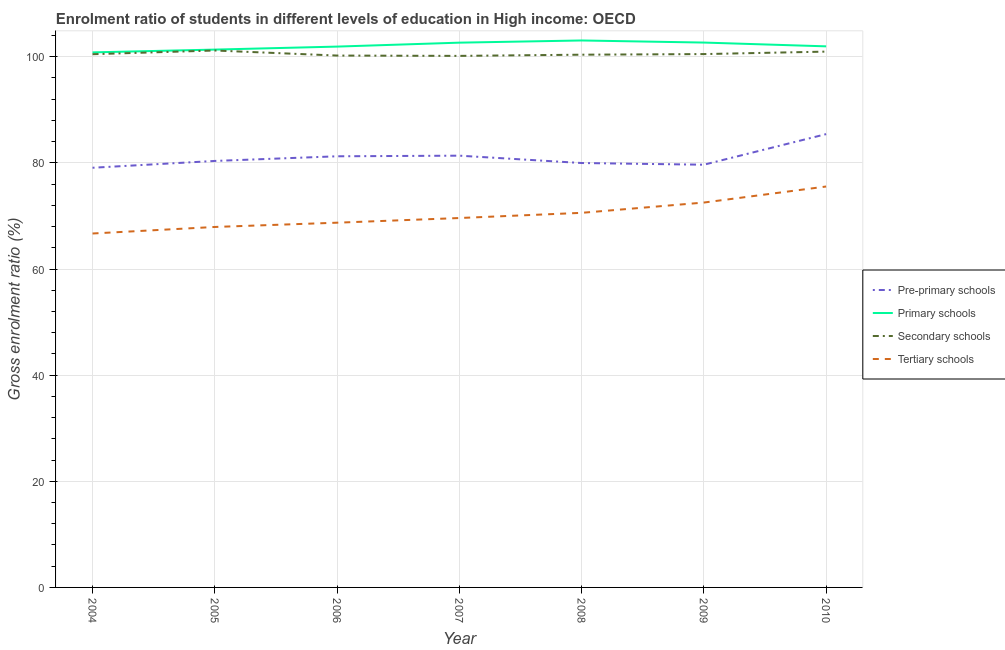How many different coloured lines are there?
Provide a succinct answer. 4. Does the line corresponding to gross enrolment ratio in pre-primary schools intersect with the line corresponding to gross enrolment ratio in tertiary schools?
Provide a short and direct response. No. What is the gross enrolment ratio in pre-primary schools in 2008?
Your answer should be compact. 79.98. Across all years, what is the maximum gross enrolment ratio in primary schools?
Keep it short and to the point. 103.07. Across all years, what is the minimum gross enrolment ratio in pre-primary schools?
Ensure brevity in your answer.  79.08. In which year was the gross enrolment ratio in tertiary schools maximum?
Your answer should be compact. 2010. What is the total gross enrolment ratio in secondary schools in the graph?
Offer a very short reply. 703.92. What is the difference between the gross enrolment ratio in secondary schools in 2008 and that in 2010?
Your response must be concise. -0.58. What is the difference between the gross enrolment ratio in tertiary schools in 2004 and the gross enrolment ratio in pre-primary schools in 2010?
Make the answer very short. -18.73. What is the average gross enrolment ratio in tertiary schools per year?
Offer a terse response. 70.23. In the year 2006, what is the difference between the gross enrolment ratio in pre-primary schools and gross enrolment ratio in tertiary schools?
Offer a terse response. 12.51. In how many years, is the gross enrolment ratio in primary schools greater than 4 %?
Give a very brief answer. 7. What is the ratio of the gross enrolment ratio in pre-primary schools in 2004 to that in 2010?
Give a very brief answer. 0.93. Is the difference between the gross enrolment ratio in tertiary schools in 2006 and 2008 greater than the difference between the gross enrolment ratio in primary schools in 2006 and 2008?
Provide a succinct answer. No. What is the difference between the highest and the second highest gross enrolment ratio in tertiary schools?
Give a very brief answer. 3.02. What is the difference between the highest and the lowest gross enrolment ratio in secondary schools?
Provide a short and direct response. 1.01. In how many years, is the gross enrolment ratio in pre-primary schools greater than the average gross enrolment ratio in pre-primary schools taken over all years?
Your answer should be very brief. 3. Is it the case that in every year, the sum of the gross enrolment ratio in secondary schools and gross enrolment ratio in pre-primary schools is greater than the sum of gross enrolment ratio in tertiary schools and gross enrolment ratio in primary schools?
Keep it short and to the point. No. Is it the case that in every year, the sum of the gross enrolment ratio in pre-primary schools and gross enrolment ratio in primary schools is greater than the gross enrolment ratio in secondary schools?
Your answer should be compact. Yes. Is the gross enrolment ratio in secondary schools strictly greater than the gross enrolment ratio in tertiary schools over the years?
Ensure brevity in your answer.  Yes. How many lines are there?
Keep it short and to the point. 4. What is the difference between two consecutive major ticks on the Y-axis?
Your answer should be very brief. 20. Where does the legend appear in the graph?
Provide a succinct answer. Center right. What is the title of the graph?
Your answer should be compact. Enrolment ratio of students in different levels of education in High income: OECD. Does "Portugal" appear as one of the legend labels in the graph?
Ensure brevity in your answer.  No. What is the label or title of the X-axis?
Offer a terse response. Year. What is the Gross enrolment ratio (%) of Pre-primary schools in 2004?
Provide a succinct answer. 79.08. What is the Gross enrolment ratio (%) in Primary schools in 2004?
Make the answer very short. 100.83. What is the Gross enrolment ratio (%) of Secondary schools in 2004?
Your answer should be compact. 100.48. What is the Gross enrolment ratio (%) of Tertiary schools in 2004?
Your response must be concise. 66.69. What is the Gross enrolment ratio (%) in Pre-primary schools in 2005?
Your answer should be very brief. 80.37. What is the Gross enrolment ratio (%) of Primary schools in 2005?
Your answer should be very brief. 101.35. What is the Gross enrolment ratio (%) of Secondary schools in 2005?
Your response must be concise. 101.18. What is the Gross enrolment ratio (%) in Tertiary schools in 2005?
Provide a succinct answer. 67.93. What is the Gross enrolment ratio (%) of Pre-primary schools in 2006?
Your response must be concise. 81.24. What is the Gross enrolment ratio (%) in Primary schools in 2006?
Ensure brevity in your answer.  101.92. What is the Gross enrolment ratio (%) of Secondary schools in 2006?
Keep it short and to the point. 100.23. What is the Gross enrolment ratio (%) in Tertiary schools in 2006?
Offer a very short reply. 68.73. What is the Gross enrolment ratio (%) of Pre-primary schools in 2007?
Keep it short and to the point. 81.36. What is the Gross enrolment ratio (%) in Primary schools in 2007?
Make the answer very short. 102.66. What is the Gross enrolment ratio (%) in Secondary schools in 2007?
Provide a succinct answer. 100.17. What is the Gross enrolment ratio (%) in Tertiary schools in 2007?
Offer a very short reply. 69.61. What is the Gross enrolment ratio (%) of Pre-primary schools in 2008?
Make the answer very short. 79.98. What is the Gross enrolment ratio (%) of Primary schools in 2008?
Your answer should be compact. 103.07. What is the Gross enrolment ratio (%) in Secondary schools in 2008?
Give a very brief answer. 100.39. What is the Gross enrolment ratio (%) in Tertiary schools in 2008?
Offer a very short reply. 70.59. What is the Gross enrolment ratio (%) of Pre-primary schools in 2009?
Provide a succinct answer. 79.66. What is the Gross enrolment ratio (%) in Primary schools in 2009?
Ensure brevity in your answer.  102.68. What is the Gross enrolment ratio (%) of Secondary schools in 2009?
Make the answer very short. 100.51. What is the Gross enrolment ratio (%) of Tertiary schools in 2009?
Offer a terse response. 72.53. What is the Gross enrolment ratio (%) of Pre-primary schools in 2010?
Your response must be concise. 85.42. What is the Gross enrolment ratio (%) of Primary schools in 2010?
Your response must be concise. 101.96. What is the Gross enrolment ratio (%) in Secondary schools in 2010?
Provide a short and direct response. 100.97. What is the Gross enrolment ratio (%) in Tertiary schools in 2010?
Give a very brief answer. 75.55. Across all years, what is the maximum Gross enrolment ratio (%) in Pre-primary schools?
Make the answer very short. 85.42. Across all years, what is the maximum Gross enrolment ratio (%) of Primary schools?
Provide a short and direct response. 103.07. Across all years, what is the maximum Gross enrolment ratio (%) in Secondary schools?
Your answer should be compact. 101.18. Across all years, what is the maximum Gross enrolment ratio (%) in Tertiary schools?
Your answer should be very brief. 75.55. Across all years, what is the minimum Gross enrolment ratio (%) of Pre-primary schools?
Provide a short and direct response. 79.08. Across all years, what is the minimum Gross enrolment ratio (%) in Primary schools?
Provide a succinct answer. 100.83. Across all years, what is the minimum Gross enrolment ratio (%) of Secondary schools?
Your answer should be very brief. 100.17. Across all years, what is the minimum Gross enrolment ratio (%) of Tertiary schools?
Your response must be concise. 66.69. What is the total Gross enrolment ratio (%) of Pre-primary schools in the graph?
Keep it short and to the point. 567.12. What is the total Gross enrolment ratio (%) in Primary schools in the graph?
Give a very brief answer. 714.46. What is the total Gross enrolment ratio (%) of Secondary schools in the graph?
Your response must be concise. 703.92. What is the total Gross enrolment ratio (%) of Tertiary schools in the graph?
Your answer should be compact. 491.63. What is the difference between the Gross enrolment ratio (%) of Pre-primary schools in 2004 and that in 2005?
Ensure brevity in your answer.  -1.28. What is the difference between the Gross enrolment ratio (%) of Primary schools in 2004 and that in 2005?
Your response must be concise. -0.52. What is the difference between the Gross enrolment ratio (%) of Secondary schools in 2004 and that in 2005?
Provide a succinct answer. -0.7. What is the difference between the Gross enrolment ratio (%) in Tertiary schools in 2004 and that in 2005?
Offer a very short reply. -1.23. What is the difference between the Gross enrolment ratio (%) in Pre-primary schools in 2004 and that in 2006?
Make the answer very short. -2.16. What is the difference between the Gross enrolment ratio (%) in Primary schools in 2004 and that in 2006?
Provide a short and direct response. -1.09. What is the difference between the Gross enrolment ratio (%) in Secondary schools in 2004 and that in 2006?
Keep it short and to the point. 0.25. What is the difference between the Gross enrolment ratio (%) of Tertiary schools in 2004 and that in 2006?
Make the answer very short. -2.04. What is the difference between the Gross enrolment ratio (%) in Pre-primary schools in 2004 and that in 2007?
Your answer should be very brief. -2.28. What is the difference between the Gross enrolment ratio (%) of Primary schools in 2004 and that in 2007?
Keep it short and to the point. -1.83. What is the difference between the Gross enrolment ratio (%) of Secondary schools in 2004 and that in 2007?
Your response must be concise. 0.32. What is the difference between the Gross enrolment ratio (%) of Tertiary schools in 2004 and that in 2007?
Ensure brevity in your answer.  -2.92. What is the difference between the Gross enrolment ratio (%) in Pre-primary schools in 2004 and that in 2008?
Offer a terse response. -0.89. What is the difference between the Gross enrolment ratio (%) in Primary schools in 2004 and that in 2008?
Keep it short and to the point. -2.24. What is the difference between the Gross enrolment ratio (%) of Secondary schools in 2004 and that in 2008?
Make the answer very short. 0.09. What is the difference between the Gross enrolment ratio (%) in Tertiary schools in 2004 and that in 2008?
Offer a terse response. -3.89. What is the difference between the Gross enrolment ratio (%) in Pre-primary schools in 2004 and that in 2009?
Your answer should be compact. -0.57. What is the difference between the Gross enrolment ratio (%) in Primary schools in 2004 and that in 2009?
Make the answer very short. -1.85. What is the difference between the Gross enrolment ratio (%) in Secondary schools in 2004 and that in 2009?
Your answer should be very brief. -0.02. What is the difference between the Gross enrolment ratio (%) of Tertiary schools in 2004 and that in 2009?
Make the answer very short. -5.83. What is the difference between the Gross enrolment ratio (%) of Pre-primary schools in 2004 and that in 2010?
Make the answer very short. -6.34. What is the difference between the Gross enrolment ratio (%) in Primary schools in 2004 and that in 2010?
Provide a succinct answer. -1.14. What is the difference between the Gross enrolment ratio (%) of Secondary schools in 2004 and that in 2010?
Ensure brevity in your answer.  -0.49. What is the difference between the Gross enrolment ratio (%) in Tertiary schools in 2004 and that in 2010?
Your response must be concise. -8.85. What is the difference between the Gross enrolment ratio (%) in Pre-primary schools in 2005 and that in 2006?
Offer a very short reply. -0.88. What is the difference between the Gross enrolment ratio (%) of Primary schools in 2005 and that in 2006?
Make the answer very short. -0.57. What is the difference between the Gross enrolment ratio (%) in Secondary schools in 2005 and that in 2006?
Provide a short and direct response. 0.95. What is the difference between the Gross enrolment ratio (%) of Tertiary schools in 2005 and that in 2006?
Your answer should be very brief. -0.81. What is the difference between the Gross enrolment ratio (%) in Pre-primary schools in 2005 and that in 2007?
Ensure brevity in your answer.  -0.99. What is the difference between the Gross enrolment ratio (%) in Primary schools in 2005 and that in 2007?
Provide a succinct answer. -1.31. What is the difference between the Gross enrolment ratio (%) in Secondary schools in 2005 and that in 2007?
Provide a short and direct response. 1.01. What is the difference between the Gross enrolment ratio (%) in Tertiary schools in 2005 and that in 2007?
Make the answer very short. -1.69. What is the difference between the Gross enrolment ratio (%) in Pre-primary schools in 2005 and that in 2008?
Your answer should be compact. 0.39. What is the difference between the Gross enrolment ratio (%) in Primary schools in 2005 and that in 2008?
Keep it short and to the point. -1.72. What is the difference between the Gross enrolment ratio (%) in Secondary schools in 2005 and that in 2008?
Ensure brevity in your answer.  0.79. What is the difference between the Gross enrolment ratio (%) of Tertiary schools in 2005 and that in 2008?
Make the answer very short. -2.66. What is the difference between the Gross enrolment ratio (%) in Pre-primary schools in 2005 and that in 2009?
Offer a very short reply. 0.71. What is the difference between the Gross enrolment ratio (%) in Primary schools in 2005 and that in 2009?
Keep it short and to the point. -1.33. What is the difference between the Gross enrolment ratio (%) of Secondary schools in 2005 and that in 2009?
Ensure brevity in your answer.  0.67. What is the difference between the Gross enrolment ratio (%) in Tertiary schools in 2005 and that in 2009?
Give a very brief answer. -4.6. What is the difference between the Gross enrolment ratio (%) in Pre-primary schools in 2005 and that in 2010?
Offer a very short reply. -5.05. What is the difference between the Gross enrolment ratio (%) of Primary schools in 2005 and that in 2010?
Offer a very short reply. -0.61. What is the difference between the Gross enrolment ratio (%) in Secondary schools in 2005 and that in 2010?
Offer a terse response. 0.21. What is the difference between the Gross enrolment ratio (%) of Tertiary schools in 2005 and that in 2010?
Give a very brief answer. -7.62. What is the difference between the Gross enrolment ratio (%) of Pre-primary schools in 2006 and that in 2007?
Ensure brevity in your answer.  -0.12. What is the difference between the Gross enrolment ratio (%) of Primary schools in 2006 and that in 2007?
Your response must be concise. -0.74. What is the difference between the Gross enrolment ratio (%) in Secondary schools in 2006 and that in 2007?
Your response must be concise. 0.06. What is the difference between the Gross enrolment ratio (%) of Tertiary schools in 2006 and that in 2007?
Keep it short and to the point. -0.88. What is the difference between the Gross enrolment ratio (%) of Pre-primary schools in 2006 and that in 2008?
Give a very brief answer. 1.27. What is the difference between the Gross enrolment ratio (%) of Primary schools in 2006 and that in 2008?
Your response must be concise. -1.15. What is the difference between the Gross enrolment ratio (%) in Secondary schools in 2006 and that in 2008?
Your answer should be very brief. -0.16. What is the difference between the Gross enrolment ratio (%) in Tertiary schools in 2006 and that in 2008?
Provide a short and direct response. -1.86. What is the difference between the Gross enrolment ratio (%) of Pre-primary schools in 2006 and that in 2009?
Ensure brevity in your answer.  1.59. What is the difference between the Gross enrolment ratio (%) of Primary schools in 2006 and that in 2009?
Make the answer very short. -0.76. What is the difference between the Gross enrolment ratio (%) of Secondary schools in 2006 and that in 2009?
Ensure brevity in your answer.  -0.28. What is the difference between the Gross enrolment ratio (%) of Tertiary schools in 2006 and that in 2009?
Offer a terse response. -3.8. What is the difference between the Gross enrolment ratio (%) in Pre-primary schools in 2006 and that in 2010?
Provide a short and direct response. -4.18. What is the difference between the Gross enrolment ratio (%) of Primary schools in 2006 and that in 2010?
Your answer should be compact. -0.05. What is the difference between the Gross enrolment ratio (%) in Secondary schools in 2006 and that in 2010?
Provide a short and direct response. -0.74. What is the difference between the Gross enrolment ratio (%) in Tertiary schools in 2006 and that in 2010?
Offer a terse response. -6.82. What is the difference between the Gross enrolment ratio (%) of Pre-primary schools in 2007 and that in 2008?
Provide a succinct answer. 1.38. What is the difference between the Gross enrolment ratio (%) in Primary schools in 2007 and that in 2008?
Ensure brevity in your answer.  -0.41. What is the difference between the Gross enrolment ratio (%) of Secondary schools in 2007 and that in 2008?
Provide a short and direct response. -0.22. What is the difference between the Gross enrolment ratio (%) in Tertiary schools in 2007 and that in 2008?
Keep it short and to the point. -0.98. What is the difference between the Gross enrolment ratio (%) of Pre-primary schools in 2007 and that in 2009?
Your response must be concise. 1.7. What is the difference between the Gross enrolment ratio (%) in Primary schools in 2007 and that in 2009?
Keep it short and to the point. -0.02. What is the difference between the Gross enrolment ratio (%) in Secondary schools in 2007 and that in 2009?
Make the answer very short. -0.34. What is the difference between the Gross enrolment ratio (%) in Tertiary schools in 2007 and that in 2009?
Provide a succinct answer. -2.92. What is the difference between the Gross enrolment ratio (%) of Pre-primary schools in 2007 and that in 2010?
Your answer should be compact. -4.06. What is the difference between the Gross enrolment ratio (%) in Primary schools in 2007 and that in 2010?
Ensure brevity in your answer.  0.7. What is the difference between the Gross enrolment ratio (%) of Secondary schools in 2007 and that in 2010?
Offer a terse response. -0.81. What is the difference between the Gross enrolment ratio (%) of Tertiary schools in 2007 and that in 2010?
Keep it short and to the point. -5.94. What is the difference between the Gross enrolment ratio (%) in Pre-primary schools in 2008 and that in 2009?
Ensure brevity in your answer.  0.32. What is the difference between the Gross enrolment ratio (%) of Primary schools in 2008 and that in 2009?
Offer a terse response. 0.39. What is the difference between the Gross enrolment ratio (%) of Secondary schools in 2008 and that in 2009?
Give a very brief answer. -0.12. What is the difference between the Gross enrolment ratio (%) of Tertiary schools in 2008 and that in 2009?
Keep it short and to the point. -1.94. What is the difference between the Gross enrolment ratio (%) of Pre-primary schools in 2008 and that in 2010?
Give a very brief answer. -5.45. What is the difference between the Gross enrolment ratio (%) of Primary schools in 2008 and that in 2010?
Keep it short and to the point. 1.11. What is the difference between the Gross enrolment ratio (%) of Secondary schools in 2008 and that in 2010?
Give a very brief answer. -0.58. What is the difference between the Gross enrolment ratio (%) in Tertiary schools in 2008 and that in 2010?
Offer a very short reply. -4.96. What is the difference between the Gross enrolment ratio (%) in Pre-primary schools in 2009 and that in 2010?
Provide a short and direct response. -5.76. What is the difference between the Gross enrolment ratio (%) in Primary schools in 2009 and that in 2010?
Your response must be concise. 0.71. What is the difference between the Gross enrolment ratio (%) in Secondary schools in 2009 and that in 2010?
Make the answer very short. -0.47. What is the difference between the Gross enrolment ratio (%) in Tertiary schools in 2009 and that in 2010?
Your response must be concise. -3.02. What is the difference between the Gross enrolment ratio (%) of Pre-primary schools in 2004 and the Gross enrolment ratio (%) of Primary schools in 2005?
Your answer should be compact. -22.27. What is the difference between the Gross enrolment ratio (%) in Pre-primary schools in 2004 and the Gross enrolment ratio (%) in Secondary schools in 2005?
Provide a succinct answer. -22.1. What is the difference between the Gross enrolment ratio (%) of Pre-primary schools in 2004 and the Gross enrolment ratio (%) of Tertiary schools in 2005?
Make the answer very short. 11.16. What is the difference between the Gross enrolment ratio (%) in Primary schools in 2004 and the Gross enrolment ratio (%) in Secondary schools in 2005?
Your answer should be compact. -0.36. What is the difference between the Gross enrolment ratio (%) of Primary schools in 2004 and the Gross enrolment ratio (%) of Tertiary schools in 2005?
Offer a very short reply. 32.9. What is the difference between the Gross enrolment ratio (%) in Secondary schools in 2004 and the Gross enrolment ratio (%) in Tertiary schools in 2005?
Ensure brevity in your answer.  32.55. What is the difference between the Gross enrolment ratio (%) in Pre-primary schools in 2004 and the Gross enrolment ratio (%) in Primary schools in 2006?
Keep it short and to the point. -22.83. What is the difference between the Gross enrolment ratio (%) in Pre-primary schools in 2004 and the Gross enrolment ratio (%) in Secondary schools in 2006?
Offer a very short reply. -21.14. What is the difference between the Gross enrolment ratio (%) of Pre-primary schools in 2004 and the Gross enrolment ratio (%) of Tertiary schools in 2006?
Offer a terse response. 10.35. What is the difference between the Gross enrolment ratio (%) of Primary schools in 2004 and the Gross enrolment ratio (%) of Secondary schools in 2006?
Make the answer very short. 0.6. What is the difference between the Gross enrolment ratio (%) in Primary schools in 2004 and the Gross enrolment ratio (%) in Tertiary schools in 2006?
Your answer should be very brief. 32.09. What is the difference between the Gross enrolment ratio (%) of Secondary schools in 2004 and the Gross enrolment ratio (%) of Tertiary schools in 2006?
Your response must be concise. 31.75. What is the difference between the Gross enrolment ratio (%) of Pre-primary schools in 2004 and the Gross enrolment ratio (%) of Primary schools in 2007?
Make the answer very short. -23.57. What is the difference between the Gross enrolment ratio (%) in Pre-primary schools in 2004 and the Gross enrolment ratio (%) in Secondary schools in 2007?
Provide a short and direct response. -21.08. What is the difference between the Gross enrolment ratio (%) of Pre-primary schools in 2004 and the Gross enrolment ratio (%) of Tertiary schools in 2007?
Make the answer very short. 9.47. What is the difference between the Gross enrolment ratio (%) of Primary schools in 2004 and the Gross enrolment ratio (%) of Secondary schools in 2007?
Keep it short and to the point. 0.66. What is the difference between the Gross enrolment ratio (%) of Primary schools in 2004 and the Gross enrolment ratio (%) of Tertiary schools in 2007?
Ensure brevity in your answer.  31.21. What is the difference between the Gross enrolment ratio (%) of Secondary schools in 2004 and the Gross enrolment ratio (%) of Tertiary schools in 2007?
Ensure brevity in your answer.  30.87. What is the difference between the Gross enrolment ratio (%) of Pre-primary schools in 2004 and the Gross enrolment ratio (%) of Primary schools in 2008?
Offer a very short reply. -23.99. What is the difference between the Gross enrolment ratio (%) in Pre-primary schools in 2004 and the Gross enrolment ratio (%) in Secondary schools in 2008?
Offer a terse response. -21.31. What is the difference between the Gross enrolment ratio (%) in Pre-primary schools in 2004 and the Gross enrolment ratio (%) in Tertiary schools in 2008?
Provide a short and direct response. 8.49. What is the difference between the Gross enrolment ratio (%) of Primary schools in 2004 and the Gross enrolment ratio (%) of Secondary schools in 2008?
Provide a short and direct response. 0.44. What is the difference between the Gross enrolment ratio (%) of Primary schools in 2004 and the Gross enrolment ratio (%) of Tertiary schools in 2008?
Offer a very short reply. 30.24. What is the difference between the Gross enrolment ratio (%) of Secondary schools in 2004 and the Gross enrolment ratio (%) of Tertiary schools in 2008?
Your response must be concise. 29.89. What is the difference between the Gross enrolment ratio (%) of Pre-primary schools in 2004 and the Gross enrolment ratio (%) of Primary schools in 2009?
Provide a short and direct response. -23.59. What is the difference between the Gross enrolment ratio (%) of Pre-primary schools in 2004 and the Gross enrolment ratio (%) of Secondary schools in 2009?
Provide a succinct answer. -21.42. What is the difference between the Gross enrolment ratio (%) in Pre-primary schools in 2004 and the Gross enrolment ratio (%) in Tertiary schools in 2009?
Offer a very short reply. 6.56. What is the difference between the Gross enrolment ratio (%) in Primary schools in 2004 and the Gross enrolment ratio (%) in Secondary schools in 2009?
Your response must be concise. 0.32. What is the difference between the Gross enrolment ratio (%) in Primary schools in 2004 and the Gross enrolment ratio (%) in Tertiary schools in 2009?
Offer a terse response. 28.3. What is the difference between the Gross enrolment ratio (%) in Secondary schools in 2004 and the Gross enrolment ratio (%) in Tertiary schools in 2009?
Provide a short and direct response. 27.95. What is the difference between the Gross enrolment ratio (%) of Pre-primary schools in 2004 and the Gross enrolment ratio (%) of Primary schools in 2010?
Ensure brevity in your answer.  -22.88. What is the difference between the Gross enrolment ratio (%) of Pre-primary schools in 2004 and the Gross enrolment ratio (%) of Secondary schools in 2010?
Ensure brevity in your answer.  -21.89. What is the difference between the Gross enrolment ratio (%) of Pre-primary schools in 2004 and the Gross enrolment ratio (%) of Tertiary schools in 2010?
Provide a short and direct response. 3.53. What is the difference between the Gross enrolment ratio (%) of Primary schools in 2004 and the Gross enrolment ratio (%) of Secondary schools in 2010?
Your answer should be compact. -0.15. What is the difference between the Gross enrolment ratio (%) of Primary schools in 2004 and the Gross enrolment ratio (%) of Tertiary schools in 2010?
Provide a succinct answer. 25.28. What is the difference between the Gross enrolment ratio (%) of Secondary schools in 2004 and the Gross enrolment ratio (%) of Tertiary schools in 2010?
Your answer should be compact. 24.93. What is the difference between the Gross enrolment ratio (%) of Pre-primary schools in 2005 and the Gross enrolment ratio (%) of Primary schools in 2006?
Give a very brief answer. -21.55. What is the difference between the Gross enrolment ratio (%) in Pre-primary schools in 2005 and the Gross enrolment ratio (%) in Secondary schools in 2006?
Offer a terse response. -19.86. What is the difference between the Gross enrolment ratio (%) of Pre-primary schools in 2005 and the Gross enrolment ratio (%) of Tertiary schools in 2006?
Keep it short and to the point. 11.64. What is the difference between the Gross enrolment ratio (%) of Primary schools in 2005 and the Gross enrolment ratio (%) of Secondary schools in 2006?
Ensure brevity in your answer.  1.12. What is the difference between the Gross enrolment ratio (%) in Primary schools in 2005 and the Gross enrolment ratio (%) in Tertiary schools in 2006?
Give a very brief answer. 32.62. What is the difference between the Gross enrolment ratio (%) in Secondary schools in 2005 and the Gross enrolment ratio (%) in Tertiary schools in 2006?
Offer a terse response. 32.45. What is the difference between the Gross enrolment ratio (%) of Pre-primary schools in 2005 and the Gross enrolment ratio (%) of Primary schools in 2007?
Your response must be concise. -22.29. What is the difference between the Gross enrolment ratio (%) of Pre-primary schools in 2005 and the Gross enrolment ratio (%) of Secondary schools in 2007?
Provide a succinct answer. -19.8. What is the difference between the Gross enrolment ratio (%) of Pre-primary schools in 2005 and the Gross enrolment ratio (%) of Tertiary schools in 2007?
Your answer should be compact. 10.76. What is the difference between the Gross enrolment ratio (%) in Primary schools in 2005 and the Gross enrolment ratio (%) in Secondary schools in 2007?
Your response must be concise. 1.18. What is the difference between the Gross enrolment ratio (%) of Primary schools in 2005 and the Gross enrolment ratio (%) of Tertiary schools in 2007?
Keep it short and to the point. 31.74. What is the difference between the Gross enrolment ratio (%) of Secondary schools in 2005 and the Gross enrolment ratio (%) of Tertiary schools in 2007?
Keep it short and to the point. 31.57. What is the difference between the Gross enrolment ratio (%) in Pre-primary schools in 2005 and the Gross enrolment ratio (%) in Primary schools in 2008?
Your answer should be very brief. -22.7. What is the difference between the Gross enrolment ratio (%) of Pre-primary schools in 2005 and the Gross enrolment ratio (%) of Secondary schools in 2008?
Ensure brevity in your answer.  -20.02. What is the difference between the Gross enrolment ratio (%) in Pre-primary schools in 2005 and the Gross enrolment ratio (%) in Tertiary schools in 2008?
Make the answer very short. 9.78. What is the difference between the Gross enrolment ratio (%) in Primary schools in 2005 and the Gross enrolment ratio (%) in Secondary schools in 2008?
Your answer should be very brief. 0.96. What is the difference between the Gross enrolment ratio (%) in Primary schools in 2005 and the Gross enrolment ratio (%) in Tertiary schools in 2008?
Offer a terse response. 30.76. What is the difference between the Gross enrolment ratio (%) in Secondary schools in 2005 and the Gross enrolment ratio (%) in Tertiary schools in 2008?
Offer a terse response. 30.59. What is the difference between the Gross enrolment ratio (%) in Pre-primary schools in 2005 and the Gross enrolment ratio (%) in Primary schools in 2009?
Your response must be concise. -22.31. What is the difference between the Gross enrolment ratio (%) of Pre-primary schools in 2005 and the Gross enrolment ratio (%) of Secondary schools in 2009?
Give a very brief answer. -20.14. What is the difference between the Gross enrolment ratio (%) of Pre-primary schools in 2005 and the Gross enrolment ratio (%) of Tertiary schools in 2009?
Keep it short and to the point. 7.84. What is the difference between the Gross enrolment ratio (%) in Primary schools in 2005 and the Gross enrolment ratio (%) in Secondary schools in 2009?
Provide a short and direct response. 0.84. What is the difference between the Gross enrolment ratio (%) in Primary schools in 2005 and the Gross enrolment ratio (%) in Tertiary schools in 2009?
Provide a short and direct response. 28.82. What is the difference between the Gross enrolment ratio (%) of Secondary schools in 2005 and the Gross enrolment ratio (%) of Tertiary schools in 2009?
Offer a terse response. 28.65. What is the difference between the Gross enrolment ratio (%) of Pre-primary schools in 2005 and the Gross enrolment ratio (%) of Primary schools in 2010?
Keep it short and to the point. -21.59. What is the difference between the Gross enrolment ratio (%) in Pre-primary schools in 2005 and the Gross enrolment ratio (%) in Secondary schools in 2010?
Your response must be concise. -20.6. What is the difference between the Gross enrolment ratio (%) of Pre-primary schools in 2005 and the Gross enrolment ratio (%) of Tertiary schools in 2010?
Offer a very short reply. 4.82. What is the difference between the Gross enrolment ratio (%) in Primary schools in 2005 and the Gross enrolment ratio (%) in Secondary schools in 2010?
Provide a short and direct response. 0.38. What is the difference between the Gross enrolment ratio (%) of Primary schools in 2005 and the Gross enrolment ratio (%) of Tertiary schools in 2010?
Make the answer very short. 25.8. What is the difference between the Gross enrolment ratio (%) in Secondary schools in 2005 and the Gross enrolment ratio (%) in Tertiary schools in 2010?
Your answer should be compact. 25.63. What is the difference between the Gross enrolment ratio (%) of Pre-primary schools in 2006 and the Gross enrolment ratio (%) of Primary schools in 2007?
Give a very brief answer. -21.41. What is the difference between the Gross enrolment ratio (%) in Pre-primary schools in 2006 and the Gross enrolment ratio (%) in Secondary schools in 2007?
Offer a terse response. -18.92. What is the difference between the Gross enrolment ratio (%) in Pre-primary schools in 2006 and the Gross enrolment ratio (%) in Tertiary schools in 2007?
Your answer should be very brief. 11.63. What is the difference between the Gross enrolment ratio (%) in Primary schools in 2006 and the Gross enrolment ratio (%) in Secondary schools in 2007?
Make the answer very short. 1.75. What is the difference between the Gross enrolment ratio (%) of Primary schools in 2006 and the Gross enrolment ratio (%) of Tertiary schools in 2007?
Provide a short and direct response. 32.31. What is the difference between the Gross enrolment ratio (%) in Secondary schools in 2006 and the Gross enrolment ratio (%) in Tertiary schools in 2007?
Your answer should be very brief. 30.61. What is the difference between the Gross enrolment ratio (%) of Pre-primary schools in 2006 and the Gross enrolment ratio (%) of Primary schools in 2008?
Make the answer very short. -21.82. What is the difference between the Gross enrolment ratio (%) in Pre-primary schools in 2006 and the Gross enrolment ratio (%) in Secondary schools in 2008?
Offer a terse response. -19.15. What is the difference between the Gross enrolment ratio (%) in Pre-primary schools in 2006 and the Gross enrolment ratio (%) in Tertiary schools in 2008?
Ensure brevity in your answer.  10.66. What is the difference between the Gross enrolment ratio (%) in Primary schools in 2006 and the Gross enrolment ratio (%) in Secondary schools in 2008?
Provide a short and direct response. 1.53. What is the difference between the Gross enrolment ratio (%) in Primary schools in 2006 and the Gross enrolment ratio (%) in Tertiary schools in 2008?
Provide a short and direct response. 31.33. What is the difference between the Gross enrolment ratio (%) in Secondary schools in 2006 and the Gross enrolment ratio (%) in Tertiary schools in 2008?
Offer a very short reply. 29.64. What is the difference between the Gross enrolment ratio (%) of Pre-primary schools in 2006 and the Gross enrolment ratio (%) of Primary schools in 2009?
Keep it short and to the point. -21.43. What is the difference between the Gross enrolment ratio (%) of Pre-primary schools in 2006 and the Gross enrolment ratio (%) of Secondary schools in 2009?
Offer a terse response. -19.26. What is the difference between the Gross enrolment ratio (%) of Pre-primary schools in 2006 and the Gross enrolment ratio (%) of Tertiary schools in 2009?
Offer a very short reply. 8.72. What is the difference between the Gross enrolment ratio (%) of Primary schools in 2006 and the Gross enrolment ratio (%) of Secondary schools in 2009?
Give a very brief answer. 1.41. What is the difference between the Gross enrolment ratio (%) of Primary schools in 2006 and the Gross enrolment ratio (%) of Tertiary schools in 2009?
Offer a terse response. 29.39. What is the difference between the Gross enrolment ratio (%) in Secondary schools in 2006 and the Gross enrolment ratio (%) in Tertiary schools in 2009?
Provide a short and direct response. 27.7. What is the difference between the Gross enrolment ratio (%) in Pre-primary schools in 2006 and the Gross enrolment ratio (%) in Primary schools in 2010?
Ensure brevity in your answer.  -20.72. What is the difference between the Gross enrolment ratio (%) of Pre-primary schools in 2006 and the Gross enrolment ratio (%) of Secondary schools in 2010?
Ensure brevity in your answer.  -19.73. What is the difference between the Gross enrolment ratio (%) in Pre-primary schools in 2006 and the Gross enrolment ratio (%) in Tertiary schools in 2010?
Your response must be concise. 5.7. What is the difference between the Gross enrolment ratio (%) of Primary schools in 2006 and the Gross enrolment ratio (%) of Secondary schools in 2010?
Provide a short and direct response. 0.95. What is the difference between the Gross enrolment ratio (%) in Primary schools in 2006 and the Gross enrolment ratio (%) in Tertiary schools in 2010?
Offer a very short reply. 26.37. What is the difference between the Gross enrolment ratio (%) of Secondary schools in 2006 and the Gross enrolment ratio (%) of Tertiary schools in 2010?
Provide a succinct answer. 24.68. What is the difference between the Gross enrolment ratio (%) in Pre-primary schools in 2007 and the Gross enrolment ratio (%) in Primary schools in 2008?
Keep it short and to the point. -21.71. What is the difference between the Gross enrolment ratio (%) in Pre-primary schools in 2007 and the Gross enrolment ratio (%) in Secondary schools in 2008?
Give a very brief answer. -19.03. What is the difference between the Gross enrolment ratio (%) in Pre-primary schools in 2007 and the Gross enrolment ratio (%) in Tertiary schools in 2008?
Offer a very short reply. 10.77. What is the difference between the Gross enrolment ratio (%) of Primary schools in 2007 and the Gross enrolment ratio (%) of Secondary schools in 2008?
Your answer should be compact. 2.27. What is the difference between the Gross enrolment ratio (%) of Primary schools in 2007 and the Gross enrolment ratio (%) of Tertiary schools in 2008?
Give a very brief answer. 32.07. What is the difference between the Gross enrolment ratio (%) in Secondary schools in 2007 and the Gross enrolment ratio (%) in Tertiary schools in 2008?
Make the answer very short. 29.58. What is the difference between the Gross enrolment ratio (%) of Pre-primary schools in 2007 and the Gross enrolment ratio (%) of Primary schools in 2009?
Keep it short and to the point. -21.31. What is the difference between the Gross enrolment ratio (%) of Pre-primary schools in 2007 and the Gross enrolment ratio (%) of Secondary schools in 2009?
Provide a short and direct response. -19.14. What is the difference between the Gross enrolment ratio (%) of Pre-primary schools in 2007 and the Gross enrolment ratio (%) of Tertiary schools in 2009?
Make the answer very short. 8.83. What is the difference between the Gross enrolment ratio (%) of Primary schools in 2007 and the Gross enrolment ratio (%) of Secondary schools in 2009?
Your response must be concise. 2.15. What is the difference between the Gross enrolment ratio (%) in Primary schools in 2007 and the Gross enrolment ratio (%) in Tertiary schools in 2009?
Offer a terse response. 30.13. What is the difference between the Gross enrolment ratio (%) of Secondary schools in 2007 and the Gross enrolment ratio (%) of Tertiary schools in 2009?
Ensure brevity in your answer.  27.64. What is the difference between the Gross enrolment ratio (%) in Pre-primary schools in 2007 and the Gross enrolment ratio (%) in Primary schools in 2010?
Your answer should be very brief. -20.6. What is the difference between the Gross enrolment ratio (%) in Pre-primary schools in 2007 and the Gross enrolment ratio (%) in Secondary schools in 2010?
Offer a terse response. -19.61. What is the difference between the Gross enrolment ratio (%) in Pre-primary schools in 2007 and the Gross enrolment ratio (%) in Tertiary schools in 2010?
Keep it short and to the point. 5.81. What is the difference between the Gross enrolment ratio (%) of Primary schools in 2007 and the Gross enrolment ratio (%) of Secondary schools in 2010?
Your response must be concise. 1.69. What is the difference between the Gross enrolment ratio (%) of Primary schools in 2007 and the Gross enrolment ratio (%) of Tertiary schools in 2010?
Give a very brief answer. 27.11. What is the difference between the Gross enrolment ratio (%) of Secondary schools in 2007 and the Gross enrolment ratio (%) of Tertiary schools in 2010?
Make the answer very short. 24.62. What is the difference between the Gross enrolment ratio (%) of Pre-primary schools in 2008 and the Gross enrolment ratio (%) of Primary schools in 2009?
Make the answer very short. -22.7. What is the difference between the Gross enrolment ratio (%) in Pre-primary schools in 2008 and the Gross enrolment ratio (%) in Secondary schools in 2009?
Your answer should be very brief. -20.53. What is the difference between the Gross enrolment ratio (%) of Pre-primary schools in 2008 and the Gross enrolment ratio (%) of Tertiary schools in 2009?
Your response must be concise. 7.45. What is the difference between the Gross enrolment ratio (%) in Primary schools in 2008 and the Gross enrolment ratio (%) in Secondary schools in 2009?
Offer a terse response. 2.56. What is the difference between the Gross enrolment ratio (%) in Primary schools in 2008 and the Gross enrolment ratio (%) in Tertiary schools in 2009?
Keep it short and to the point. 30.54. What is the difference between the Gross enrolment ratio (%) of Secondary schools in 2008 and the Gross enrolment ratio (%) of Tertiary schools in 2009?
Provide a succinct answer. 27.86. What is the difference between the Gross enrolment ratio (%) in Pre-primary schools in 2008 and the Gross enrolment ratio (%) in Primary schools in 2010?
Your answer should be compact. -21.99. What is the difference between the Gross enrolment ratio (%) in Pre-primary schools in 2008 and the Gross enrolment ratio (%) in Secondary schools in 2010?
Your answer should be very brief. -20.99. What is the difference between the Gross enrolment ratio (%) of Pre-primary schools in 2008 and the Gross enrolment ratio (%) of Tertiary schools in 2010?
Ensure brevity in your answer.  4.43. What is the difference between the Gross enrolment ratio (%) of Primary schools in 2008 and the Gross enrolment ratio (%) of Secondary schools in 2010?
Make the answer very short. 2.1. What is the difference between the Gross enrolment ratio (%) of Primary schools in 2008 and the Gross enrolment ratio (%) of Tertiary schools in 2010?
Your response must be concise. 27.52. What is the difference between the Gross enrolment ratio (%) in Secondary schools in 2008 and the Gross enrolment ratio (%) in Tertiary schools in 2010?
Offer a terse response. 24.84. What is the difference between the Gross enrolment ratio (%) in Pre-primary schools in 2009 and the Gross enrolment ratio (%) in Primary schools in 2010?
Offer a very short reply. -22.3. What is the difference between the Gross enrolment ratio (%) of Pre-primary schools in 2009 and the Gross enrolment ratio (%) of Secondary schools in 2010?
Your answer should be very brief. -21.31. What is the difference between the Gross enrolment ratio (%) of Pre-primary schools in 2009 and the Gross enrolment ratio (%) of Tertiary schools in 2010?
Make the answer very short. 4.11. What is the difference between the Gross enrolment ratio (%) of Primary schools in 2009 and the Gross enrolment ratio (%) of Secondary schools in 2010?
Your response must be concise. 1.7. What is the difference between the Gross enrolment ratio (%) of Primary schools in 2009 and the Gross enrolment ratio (%) of Tertiary schools in 2010?
Ensure brevity in your answer.  27.13. What is the difference between the Gross enrolment ratio (%) in Secondary schools in 2009 and the Gross enrolment ratio (%) in Tertiary schools in 2010?
Ensure brevity in your answer.  24.96. What is the average Gross enrolment ratio (%) of Pre-primary schools per year?
Ensure brevity in your answer.  81.02. What is the average Gross enrolment ratio (%) of Primary schools per year?
Give a very brief answer. 102.07. What is the average Gross enrolment ratio (%) in Secondary schools per year?
Your answer should be very brief. 100.56. What is the average Gross enrolment ratio (%) of Tertiary schools per year?
Make the answer very short. 70.23. In the year 2004, what is the difference between the Gross enrolment ratio (%) in Pre-primary schools and Gross enrolment ratio (%) in Primary schools?
Offer a very short reply. -21.74. In the year 2004, what is the difference between the Gross enrolment ratio (%) of Pre-primary schools and Gross enrolment ratio (%) of Secondary schools?
Make the answer very short. -21.4. In the year 2004, what is the difference between the Gross enrolment ratio (%) in Pre-primary schools and Gross enrolment ratio (%) in Tertiary schools?
Your response must be concise. 12.39. In the year 2004, what is the difference between the Gross enrolment ratio (%) of Primary schools and Gross enrolment ratio (%) of Secondary schools?
Offer a very short reply. 0.34. In the year 2004, what is the difference between the Gross enrolment ratio (%) of Primary schools and Gross enrolment ratio (%) of Tertiary schools?
Give a very brief answer. 34.13. In the year 2004, what is the difference between the Gross enrolment ratio (%) in Secondary schools and Gross enrolment ratio (%) in Tertiary schools?
Your response must be concise. 33.79. In the year 2005, what is the difference between the Gross enrolment ratio (%) in Pre-primary schools and Gross enrolment ratio (%) in Primary schools?
Offer a very short reply. -20.98. In the year 2005, what is the difference between the Gross enrolment ratio (%) in Pre-primary schools and Gross enrolment ratio (%) in Secondary schools?
Give a very brief answer. -20.81. In the year 2005, what is the difference between the Gross enrolment ratio (%) in Pre-primary schools and Gross enrolment ratio (%) in Tertiary schools?
Your answer should be very brief. 12.44. In the year 2005, what is the difference between the Gross enrolment ratio (%) in Primary schools and Gross enrolment ratio (%) in Secondary schools?
Offer a very short reply. 0.17. In the year 2005, what is the difference between the Gross enrolment ratio (%) of Primary schools and Gross enrolment ratio (%) of Tertiary schools?
Your response must be concise. 33.42. In the year 2005, what is the difference between the Gross enrolment ratio (%) in Secondary schools and Gross enrolment ratio (%) in Tertiary schools?
Give a very brief answer. 33.25. In the year 2006, what is the difference between the Gross enrolment ratio (%) in Pre-primary schools and Gross enrolment ratio (%) in Primary schools?
Your response must be concise. -20.67. In the year 2006, what is the difference between the Gross enrolment ratio (%) in Pre-primary schools and Gross enrolment ratio (%) in Secondary schools?
Your answer should be compact. -18.98. In the year 2006, what is the difference between the Gross enrolment ratio (%) of Pre-primary schools and Gross enrolment ratio (%) of Tertiary schools?
Offer a very short reply. 12.51. In the year 2006, what is the difference between the Gross enrolment ratio (%) of Primary schools and Gross enrolment ratio (%) of Secondary schools?
Ensure brevity in your answer.  1.69. In the year 2006, what is the difference between the Gross enrolment ratio (%) of Primary schools and Gross enrolment ratio (%) of Tertiary schools?
Your answer should be very brief. 33.19. In the year 2006, what is the difference between the Gross enrolment ratio (%) in Secondary schools and Gross enrolment ratio (%) in Tertiary schools?
Your answer should be very brief. 31.49. In the year 2007, what is the difference between the Gross enrolment ratio (%) of Pre-primary schools and Gross enrolment ratio (%) of Primary schools?
Offer a very short reply. -21.3. In the year 2007, what is the difference between the Gross enrolment ratio (%) in Pre-primary schools and Gross enrolment ratio (%) in Secondary schools?
Give a very brief answer. -18.8. In the year 2007, what is the difference between the Gross enrolment ratio (%) in Pre-primary schools and Gross enrolment ratio (%) in Tertiary schools?
Provide a short and direct response. 11.75. In the year 2007, what is the difference between the Gross enrolment ratio (%) of Primary schools and Gross enrolment ratio (%) of Secondary schools?
Your response must be concise. 2.49. In the year 2007, what is the difference between the Gross enrolment ratio (%) in Primary schools and Gross enrolment ratio (%) in Tertiary schools?
Offer a very short reply. 33.05. In the year 2007, what is the difference between the Gross enrolment ratio (%) of Secondary schools and Gross enrolment ratio (%) of Tertiary schools?
Your answer should be compact. 30.55. In the year 2008, what is the difference between the Gross enrolment ratio (%) of Pre-primary schools and Gross enrolment ratio (%) of Primary schools?
Your answer should be compact. -23.09. In the year 2008, what is the difference between the Gross enrolment ratio (%) in Pre-primary schools and Gross enrolment ratio (%) in Secondary schools?
Offer a very short reply. -20.41. In the year 2008, what is the difference between the Gross enrolment ratio (%) in Pre-primary schools and Gross enrolment ratio (%) in Tertiary schools?
Offer a very short reply. 9.39. In the year 2008, what is the difference between the Gross enrolment ratio (%) in Primary schools and Gross enrolment ratio (%) in Secondary schools?
Keep it short and to the point. 2.68. In the year 2008, what is the difference between the Gross enrolment ratio (%) in Primary schools and Gross enrolment ratio (%) in Tertiary schools?
Your answer should be compact. 32.48. In the year 2008, what is the difference between the Gross enrolment ratio (%) of Secondary schools and Gross enrolment ratio (%) of Tertiary schools?
Your answer should be very brief. 29.8. In the year 2009, what is the difference between the Gross enrolment ratio (%) of Pre-primary schools and Gross enrolment ratio (%) of Primary schools?
Make the answer very short. -23.02. In the year 2009, what is the difference between the Gross enrolment ratio (%) of Pre-primary schools and Gross enrolment ratio (%) of Secondary schools?
Provide a succinct answer. -20.85. In the year 2009, what is the difference between the Gross enrolment ratio (%) in Pre-primary schools and Gross enrolment ratio (%) in Tertiary schools?
Offer a terse response. 7.13. In the year 2009, what is the difference between the Gross enrolment ratio (%) in Primary schools and Gross enrolment ratio (%) in Secondary schools?
Keep it short and to the point. 2.17. In the year 2009, what is the difference between the Gross enrolment ratio (%) in Primary schools and Gross enrolment ratio (%) in Tertiary schools?
Make the answer very short. 30.15. In the year 2009, what is the difference between the Gross enrolment ratio (%) in Secondary schools and Gross enrolment ratio (%) in Tertiary schools?
Offer a terse response. 27.98. In the year 2010, what is the difference between the Gross enrolment ratio (%) of Pre-primary schools and Gross enrolment ratio (%) of Primary schools?
Offer a very short reply. -16.54. In the year 2010, what is the difference between the Gross enrolment ratio (%) in Pre-primary schools and Gross enrolment ratio (%) in Secondary schools?
Offer a very short reply. -15.55. In the year 2010, what is the difference between the Gross enrolment ratio (%) of Pre-primary schools and Gross enrolment ratio (%) of Tertiary schools?
Your response must be concise. 9.87. In the year 2010, what is the difference between the Gross enrolment ratio (%) in Primary schools and Gross enrolment ratio (%) in Tertiary schools?
Keep it short and to the point. 26.41. In the year 2010, what is the difference between the Gross enrolment ratio (%) of Secondary schools and Gross enrolment ratio (%) of Tertiary schools?
Keep it short and to the point. 25.42. What is the ratio of the Gross enrolment ratio (%) of Primary schools in 2004 to that in 2005?
Keep it short and to the point. 0.99. What is the ratio of the Gross enrolment ratio (%) of Tertiary schools in 2004 to that in 2005?
Offer a terse response. 0.98. What is the ratio of the Gross enrolment ratio (%) in Pre-primary schools in 2004 to that in 2006?
Make the answer very short. 0.97. What is the ratio of the Gross enrolment ratio (%) of Primary schools in 2004 to that in 2006?
Your response must be concise. 0.99. What is the ratio of the Gross enrolment ratio (%) in Secondary schools in 2004 to that in 2006?
Make the answer very short. 1. What is the ratio of the Gross enrolment ratio (%) of Tertiary schools in 2004 to that in 2006?
Provide a short and direct response. 0.97. What is the ratio of the Gross enrolment ratio (%) of Primary schools in 2004 to that in 2007?
Ensure brevity in your answer.  0.98. What is the ratio of the Gross enrolment ratio (%) in Secondary schools in 2004 to that in 2007?
Offer a terse response. 1. What is the ratio of the Gross enrolment ratio (%) of Tertiary schools in 2004 to that in 2007?
Offer a very short reply. 0.96. What is the ratio of the Gross enrolment ratio (%) of Pre-primary schools in 2004 to that in 2008?
Make the answer very short. 0.99. What is the ratio of the Gross enrolment ratio (%) of Primary schools in 2004 to that in 2008?
Give a very brief answer. 0.98. What is the ratio of the Gross enrolment ratio (%) of Tertiary schools in 2004 to that in 2008?
Offer a very short reply. 0.94. What is the ratio of the Gross enrolment ratio (%) of Primary schools in 2004 to that in 2009?
Offer a very short reply. 0.98. What is the ratio of the Gross enrolment ratio (%) in Tertiary schools in 2004 to that in 2009?
Give a very brief answer. 0.92. What is the ratio of the Gross enrolment ratio (%) in Pre-primary schools in 2004 to that in 2010?
Ensure brevity in your answer.  0.93. What is the ratio of the Gross enrolment ratio (%) of Primary schools in 2004 to that in 2010?
Your answer should be very brief. 0.99. What is the ratio of the Gross enrolment ratio (%) in Tertiary schools in 2004 to that in 2010?
Provide a succinct answer. 0.88. What is the ratio of the Gross enrolment ratio (%) of Pre-primary schools in 2005 to that in 2006?
Provide a short and direct response. 0.99. What is the ratio of the Gross enrolment ratio (%) of Secondary schools in 2005 to that in 2006?
Keep it short and to the point. 1.01. What is the ratio of the Gross enrolment ratio (%) in Tertiary schools in 2005 to that in 2006?
Provide a succinct answer. 0.99. What is the ratio of the Gross enrolment ratio (%) of Pre-primary schools in 2005 to that in 2007?
Keep it short and to the point. 0.99. What is the ratio of the Gross enrolment ratio (%) in Primary schools in 2005 to that in 2007?
Your answer should be compact. 0.99. What is the ratio of the Gross enrolment ratio (%) of Secondary schools in 2005 to that in 2007?
Provide a succinct answer. 1.01. What is the ratio of the Gross enrolment ratio (%) in Tertiary schools in 2005 to that in 2007?
Your response must be concise. 0.98. What is the ratio of the Gross enrolment ratio (%) of Primary schools in 2005 to that in 2008?
Provide a short and direct response. 0.98. What is the ratio of the Gross enrolment ratio (%) of Secondary schools in 2005 to that in 2008?
Make the answer very short. 1.01. What is the ratio of the Gross enrolment ratio (%) of Tertiary schools in 2005 to that in 2008?
Provide a succinct answer. 0.96. What is the ratio of the Gross enrolment ratio (%) of Pre-primary schools in 2005 to that in 2009?
Ensure brevity in your answer.  1.01. What is the ratio of the Gross enrolment ratio (%) of Primary schools in 2005 to that in 2009?
Ensure brevity in your answer.  0.99. What is the ratio of the Gross enrolment ratio (%) of Secondary schools in 2005 to that in 2009?
Give a very brief answer. 1.01. What is the ratio of the Gross enrolment ratio (%) of Tertiary schools in 2005 to that in 2009?
Your answer should be compact. 0.94. What is the ratio of the Gross enrolment ratio (%) of Pre-primary schools in 2005 to that in 2010?
Ensure brevity in your answer.  0.94. What is the ratio of the Gross enrolment ratio (%) in Secondary schools in 2005 to that in 2010?
Provide a short and direct response. 1. What is the ratio of the Gross enrolment ratio (%) of Tertiary schools in 2005 to that in 2010?
Make the answer very short. 0.9. What is the ratio of the Gross enrolment ratio (%) in Primary schools in 2006 to that in 2007?
Offer a terse response. 0.99. What is the ratio of the Gross enrolment ratio (%) in Secondary schools in 2006 to that in 2007?
Keep it short and to the point. 1. What is the ratio of the Gross enrolment ratio (%) in Tertiary schools in 2006 to that in 2007?
Your answer should be compact. 0.99. What is the ratio of the Gross enrolment ratio (%) in Pre-primary schools in 2006 to that in 2008?
Keep it short and to the point. 1.02. What is the ratio of the Gross enrolment ratio (%) in Secondary schools in 2006 to that in 2008?
Provide a short and direct response. 1. What is the ratio of the Gross enrolment ratio (%) of Tertiary schools in 2006 to that in 2008?
Keep it short and to the point. 0.97. What is the ratio of the Gross enrolment ratio (%) in Pre-primary schools in 2006 to that in 2009?
Provide a succinct answer. 1.02. What is the ratio of the Gross enrolment ratio (%) in Tertiary schools in 2006 to that in 2009?
Your answer should be very brief. 0.95. What is the ratio of the Gross enrolment ratio (%) of Pre-primary schools in 2006 to that in 2010?
Provide a short and direct response. 0.95. What is the ratio of the Gross enrolment ratio (%) in Secondary schools in 2006 to that in 2010?
Your response must be concise. 0.99. What is the ratio of the Gross enrolment ratio (%) in Tertiary schools in 2006 to that in 2010?
Give a very brief answer. 0.91. What is the ratio of the Gross enrolment ratio (%) of Pre-primary schools in 2007 to that in 2008?
Your answer should be compact. 1.02. What is the ratio of the Gross enrolment ratio (%) in Primary schools in 2007 to that in 2008?
Provide a short and direct response. 1. What is the ratio of the Gross enrolment ratio (%) in Secondary schools in 2007 to that in 2008?
Give a very brief answer. 1. What is the ratio of the Gross enrolment ratio (%) in Tertiary schools in 2007 to that in 2008?
Offer a terse response. 0.99. What is the ratio of the Gross enrolment ratio (%) in Pre-primary schools in 2007 to that in 2009?
Keep it short and to the point. 1.02. What is the ratio of the Gross enrolment ratio (%) in Primary schools in 2007 to that in 2009?
Provide a short and direct response. 1. What is the ratio of the Gross enrolment ratio (%) of Secondary schools in 2007 to that in 2009?
Provide a succinct answer. 1. What is the ratio of the Gross enrolment ratio (%) of Tertiary schools in 2007 to that in 2009?
Ensure brevity in your answer.  0.96. What is the ratio of the Gross enrolment ratio (%) of Pre-primary schools in 2007 to that in 2010?
Your answer should be compact. 0.95. What is the ratio of the Gross enrolment ratio (%) in Primary schools in 2007 to that in 2010?
Offer a terse response. 1.01. What is the ratio of the Gross enrolment ratio (%) of Secondary schools in 2007 to that in 2010?
Your answer should be compact. 0.99. What is the ratio of the Gross enrolment ratio (%) of Tertiary schools in 2007 to that in 2010?
Offer a very short reply. 0.92. What is the ratio of the Gross enrolment ratio (%) of Pre-primary schools in 2008 to that in 2009?
Keep it short and to the point. 1. What is the ratio of the Gross enrolment ratio (%) in Secondary schools in 2008 to that in 2009?
Offer a terse response. 1. What is the ratio of the Gross enrolment ratio (%) of Tertiary schools in 2008 to that in 2009?
Offer a terse response. 0.97. What is the ratio of the Gross enrolment ratio (%) in Pre-primary schools in 2008 to that in 2010?
Provide a short and direct response. 0.94. What is the ratio of the Gross enrolment ratio (%) of Primary schools in 2008 to that in 2010?
Offer a terse response. 1.01. What is the ratio of the Gross enrolment ratio (%) in Tertiary schools in 2008 to that in 2010?
Your answer should be very brief. 0.93. What is the ratio of the Gross enrolment ratio (%) in Pre-primary schools in 2009 to that in 2010?
Your response must be concise. 0.93. What is the ratio of the Gross enrolment ratio (%) in Primary schools in 2009 to that in 2010?
Give a very brief answer. 1.01. What is the difference between the highest and the second highest Gross enrolment ratio (%) of Pre-primary schools?
Keep it short and to the point. 4.06. What is the difference between the highest and the second highest Gross enrolment ratio (%) of Primary schools?
Your answer should be very brief. 0.39. What is the difference between the highest and the second highest Gross enrolment ratio (%) of Secondary schools?
Make the answer very short. 0.21. What is the difference between the highest and the second highest Gross enrolment ratio (%) in Tertiary schools?
Make the answer very short. 3.02. What is the difference between the highest and the lowest Gross enrolment ratio (%) in Pre-primary schools?
Your response must be concise. 6.34. What is the difference between the highest and the lowest Gross enrolment ratio (%) in Primary schools?
Provide a short and direct response. 2.24. What is the difference between the highest and the lowest Gross enrolment ratio (%) of Secondary schools?
Your response must be concise. 1.01. What is the difference between the highest and the lowest Gross enrolment ratio (%) of Tertiary schools?
Your answer should be very brief. 8.85. 